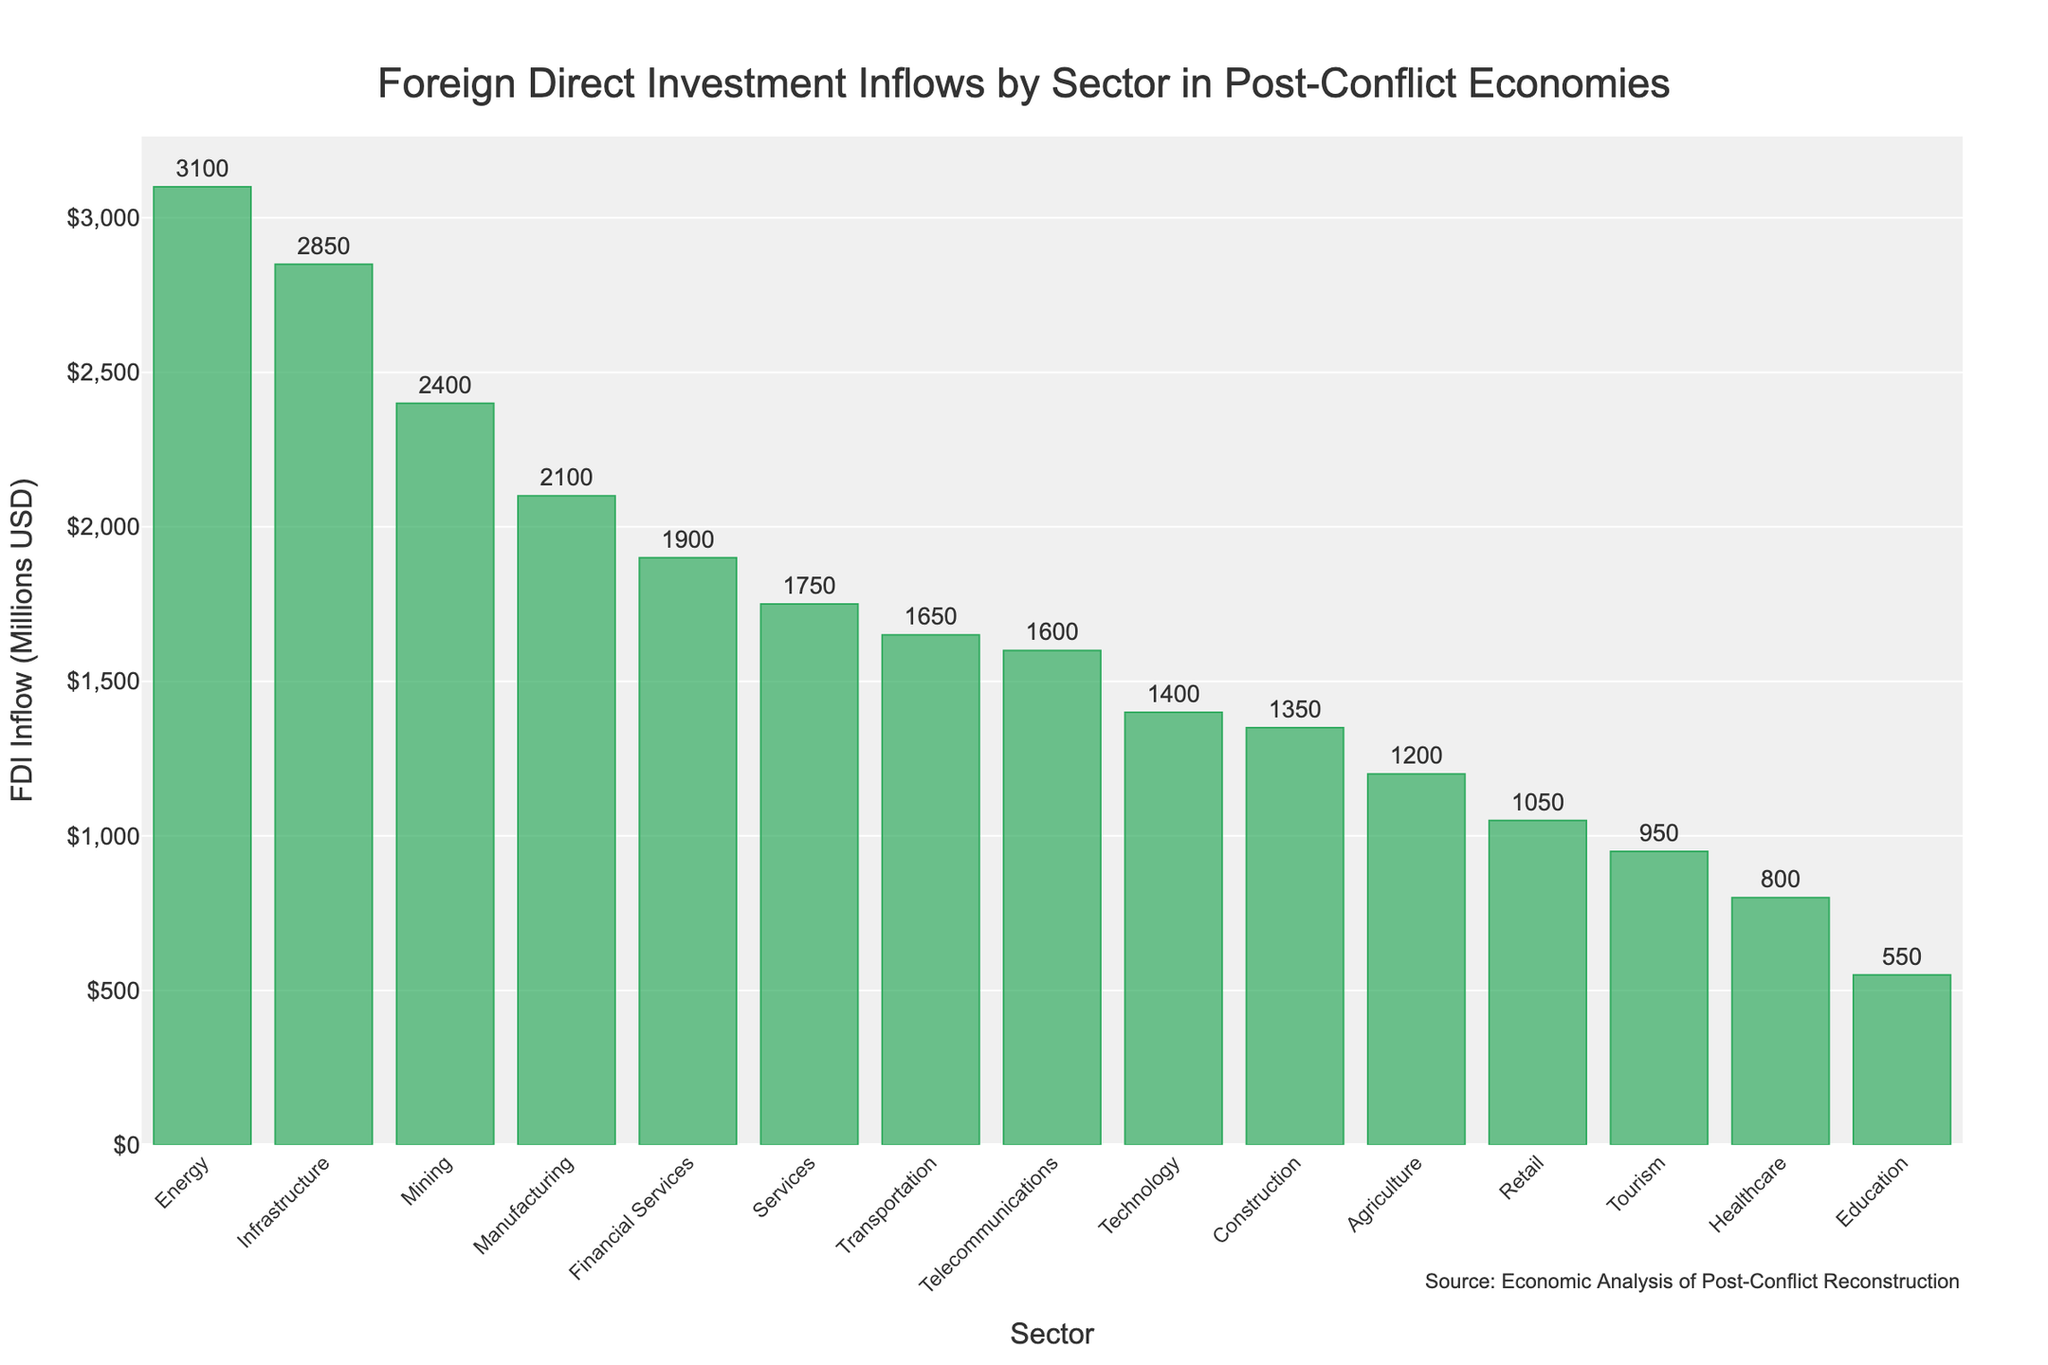Which sector has the highest FDI inflow? The bar representing 'Energy' is the tallest, indicating that it has the highest Foreign Direct Investment inflow.
Answer: Energy Which three sectors have the lowest FDI inflows? The shortest bars represent 'Education', 'Healthcare', and 'Tourism', indicating these sectors have the lowest FDI inflows.
Answer: Education, Healthcare, Tourism What is the total FDI inflow for the 'Technology' and 'Telecommunications' sectors combined? The FDI inflow for Technology is $1,400 million, and for Telecommunications, it is $1,600 million. Summing these values gives $1,400 + $1,600 = $3,000 million.
Answer: $3,000 million How much more FDI did 'Energy' receive compared to 'Tourism'? The FDI inflow for Energy is $3,100 million, and for Tourism, it is $950 million. The difference is $3,100 - $950 = $2,150 million.
Answer: $2,150 million Which sector received more FDI inflow, 'Agriculture' or 'Manufacturing'? The bar for Manufacturing is taller than that for Agriculture. Manufacturing has an FDI inflow of $2,100 million, while Agriculture has $1,200 million.
Answer: Manufacturing What is the average FDI inflow for all sectors? To find the average, sum the FDI inflows for all sectors and divide by the number of sectors. The total FDI is $2850 + $1200 + $2100 + $1750 + $3100 + $1600 + $2400 + $950 + $1350 + $800 + $550 + $1900 + $1050 + $1400 + $1650 = $25,650 million. There are 15 sectors, so the average is $25,650 / 15 = $1,710 million.
Answer: $1,710 million Which sectors received FDI inflows greater than $2,000 million? The bars for 'Energy', 'Infrastructure', 'Manufacturing', and 'Mining' all represent FDI inflows greater than $2,000 million.
Answer: Energy, Infrastructure, Manufacturing, Mining 